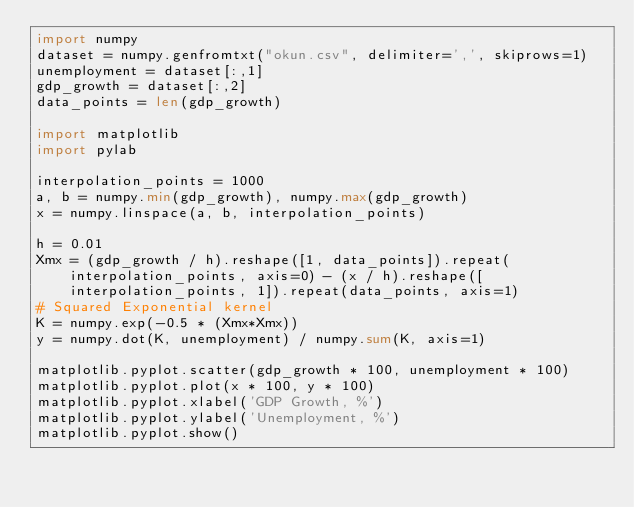Convert code to text. <code><loc_0><loc_0><loc_500><loc_500><_Python_>import numpy
dataset = numpy.genfromtxt("okun.csv", delimiter=',', skiprows=1)
unemployment = dataset[:,1]
gdp_growth = dataset[:,2]
data_points = len(gdp_growth)

import matplotlib
import pylab

interpolation_points = 1000
a, b = numpy.min(gdp_growth), numpy.max(gdp_growth)
x = numpy.linspace(a, b, interpolation_points)

h = 0.01
Xmx = (gdp_growth / h).reshape([1, data_points]).repeat(interpolation_points, axis=0) - (x / h).reshape([interpolation_points, 1]).repeat(data_points, axis=1)
# Squared Exponential kernel
K = numpy.exp(-0.5 * (Xmx*Xmx))
y = numpy.dot(K, unemployment) / numpy.sum(K, axis=1)

matplotlib.pyplot.scatter(gdp_growth * 100, unemployment * 100)
matplotlib.pyplot.plot(x * 100, y * 100)
matplotlib.pyplot.xlabel('GDP Growth, %')
matplotlib.pyplot.ylabel('Unemployment, %')
matplotlib.pyplot.show()
</code> 